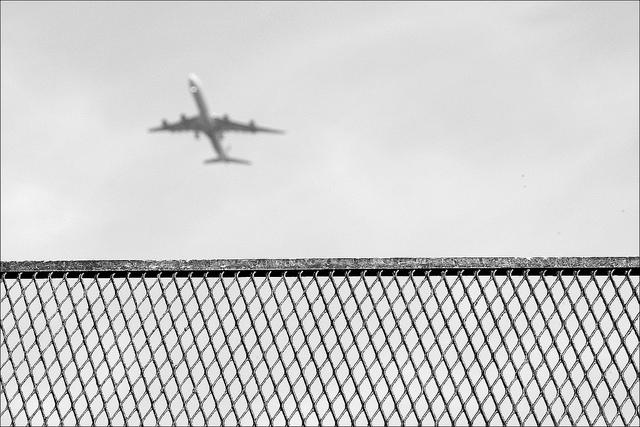What is visible in the sky?
Be succinct. Plane. What type of fence is this?
Short answer required. Chain link. What is shown in the foreground?
Concise answer only. Fence. 